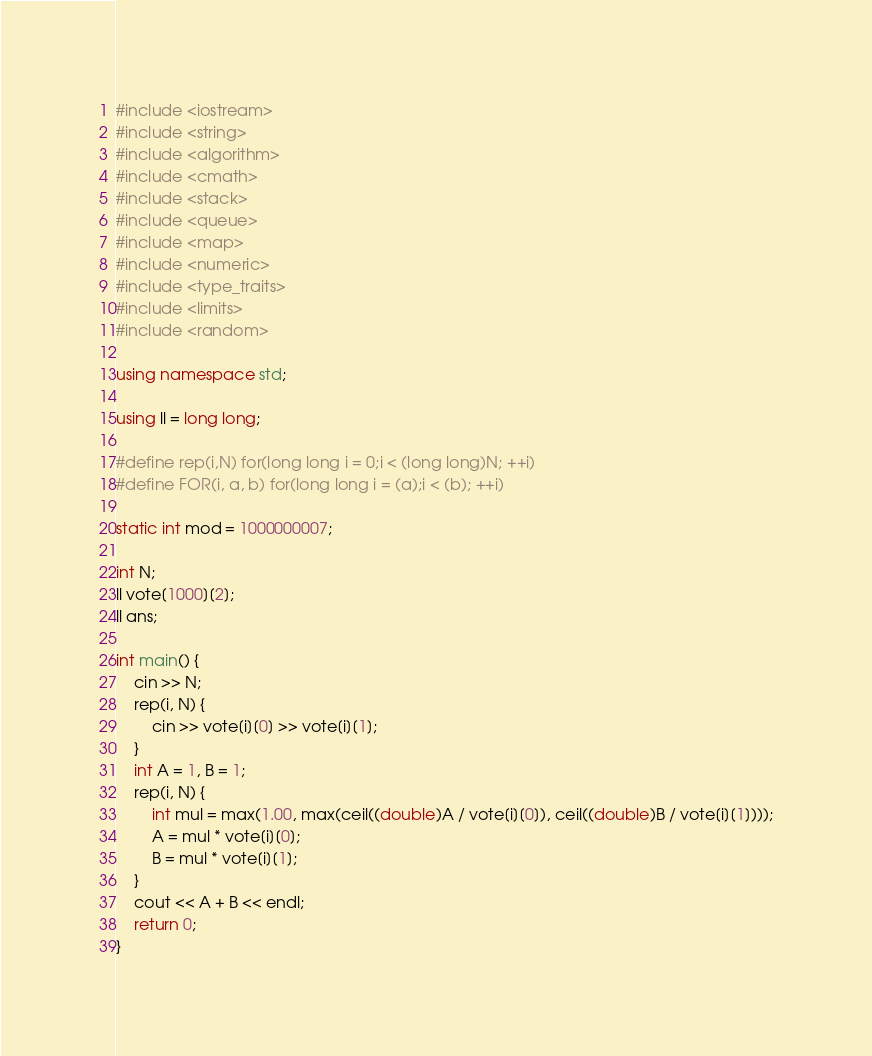<code> <loc_0><loc_0><loc_500><loc_500><_C++_>#include <iostream>
#include <string>
#include <algorithm>
#include <cmath>
#include <stack>
#include <queue>
#include <map>
#include <numeric>
#include <type_traits>
#include <limits>
#include <random>

using namespace std;

using ll = long long;

#define rep(i,N) for(long long i = 0;i < (long long)N; ++i)
#define FOR(i, a, b) for(long long i = (a);i < (b); ++i)

static int mod = 1000000007;

int N;
ll vote[1000][2];
ll ans;

int main() {
	cin >> N;
	rep(i, N) {
		cin >> vote[i][0] >> vote[i][1];
	}
	int A = 1, B = 1;
	rep(i, N) {
		int mul = max(1.00, max(ceil((double)A / vote[i][0]), ceil((double)B / vote[i][1])));
		A = mul * vote[i][0];
		B = mul * vote[i][1];
	}
	cout << A + B << endl;
	return 0;
}</code> 